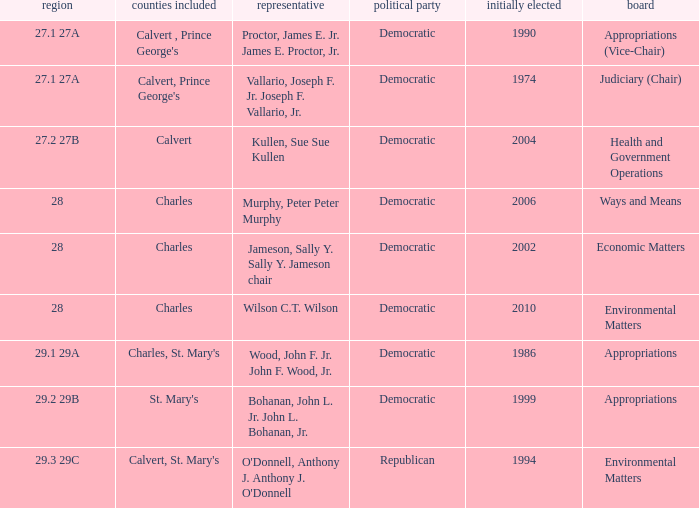In which democratic district did the vote count surpass 2006 for the first time? 28.0. 